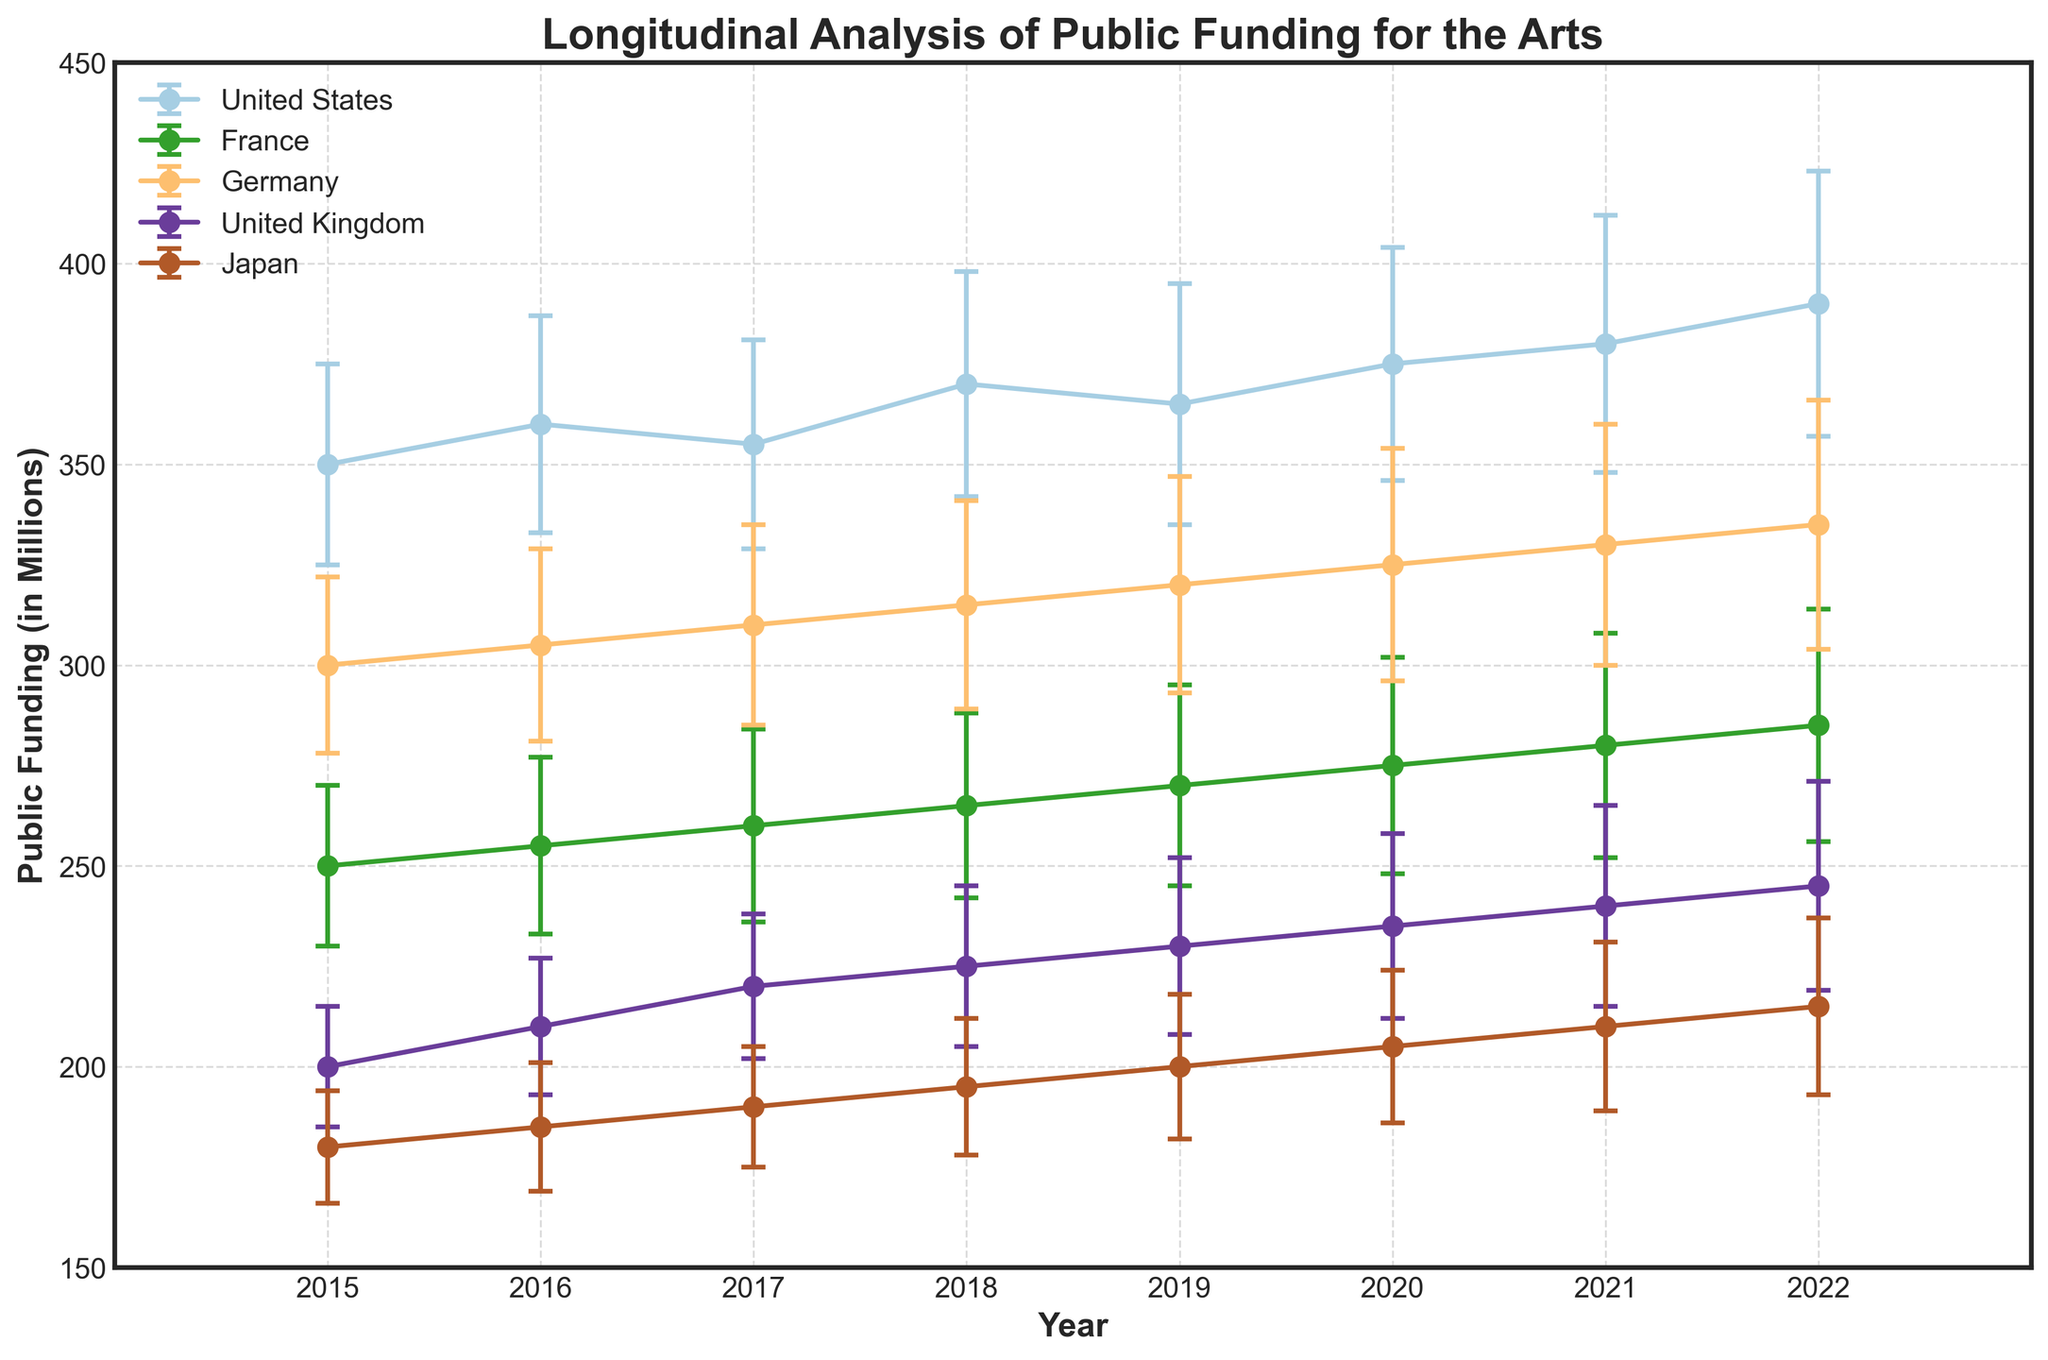What is the title of the plot? The title is typically located at the top of the figure and serves as a summary of the entire plot. In this plot, the title aligns with the focus on public funding for the arts.
Answer: Longitudinal Analysis of Public Funding for the Arts How many countries are represented in the plot? The plot uses different colors to represent each country, and these countries are listed in the legend. By counting the entries in the legend, we can determine the number of countries.
Answer: 5 What is the funding trend for the United States from 2015 to 2022? By observing the line and error bars corresponding to the United States, we can see that the public funding generally increases over the years with some variability.
Answer: Increasing trend Which country had the highest public funding for the arts in 2022? By observing the end points of the lines (2015 to 2022) for each country, it's apparent which country has the highest value in 2022.
Answer: United States What is the range of public funding for Japan in 2020? The public funding amount and its variability (error bar) for Japan in 2020 can be observed directly from the plot at the corresponding year. The range is determined by adding and subtracting the standard deviation.
Answer: 186 to 224 million How does the public funding trend in Germany compare to that in the United Kingdom from 2015 to 2022? Comparing the slopes and directions of the lines representing Germany and the United Kingdom over the years will provide insights into their trends. Germany shows a steadier and slightly higher increase compared to the more fluctuating trend of the United Kingdom.
Answer: Germany shows a steadier increase For which year did France have the lowest increase in public funding compared to the previous year? By examining consecutive data points for France and calculating the year-over-year differences, we can identify the smallest increase.
Answer: 2017 How do the error bars for the United States and France in 2016 compare? Error bars represent the variability or standard deviation of the data. Comparing these bars for the two countries in 2016 reveals that the United States has a larger error margin than France.
Answer: United States has larger error bars What year had the largest standard deviation in public funding for Germany? By observing the error bars for Germany over the years, the year with the longest error bar indicates the largest standard deviation.
Answer: 2022 Which country showed the most consistent public funding for the arts over the given period? Consistency can be judged by the overall smoothness and minimal error bars of the country's funding trend line. By examining these attributes across all countries, we conclude that Japan's line appears the most stable with relatively lower errors.
Answer: Japan 